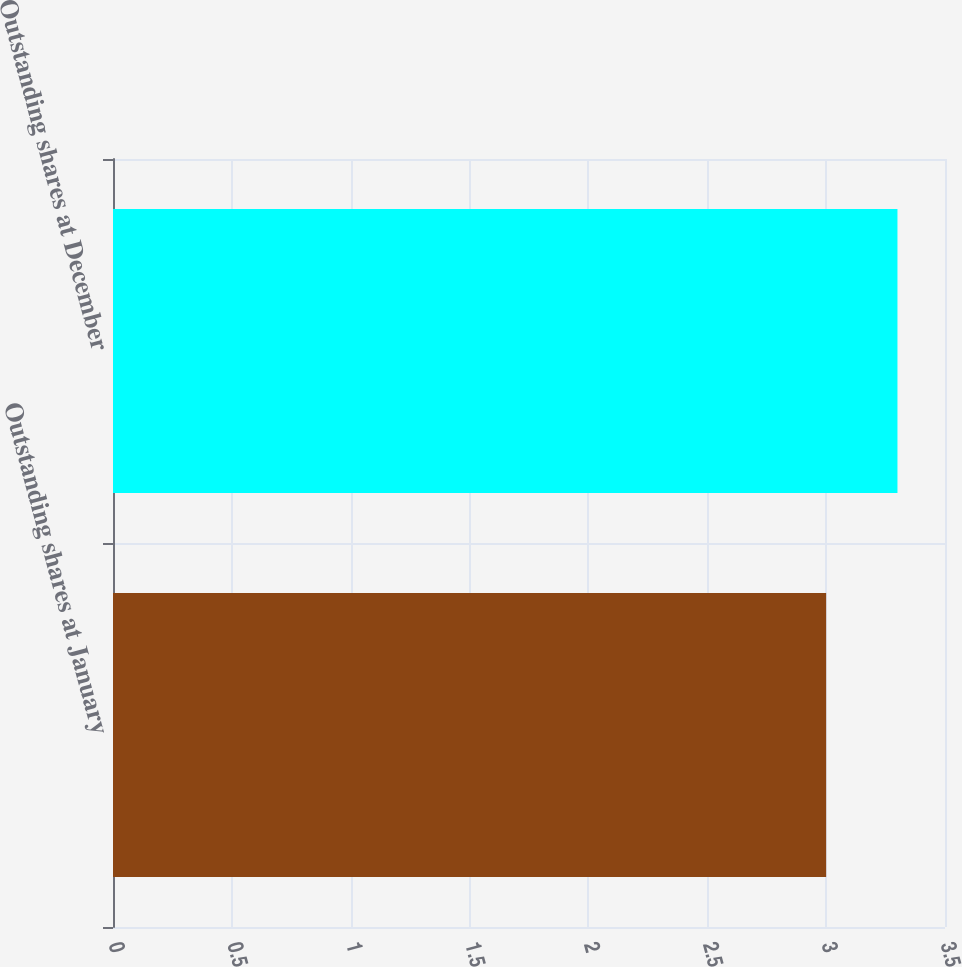<chart> <loc_0><loc_0><loc_500><loc_500><bar_chart><fcel>Outstanding shares at January<fcel>Outstanding shares at December<nl><fcel>3<fcel>3.3<nl></chart> 